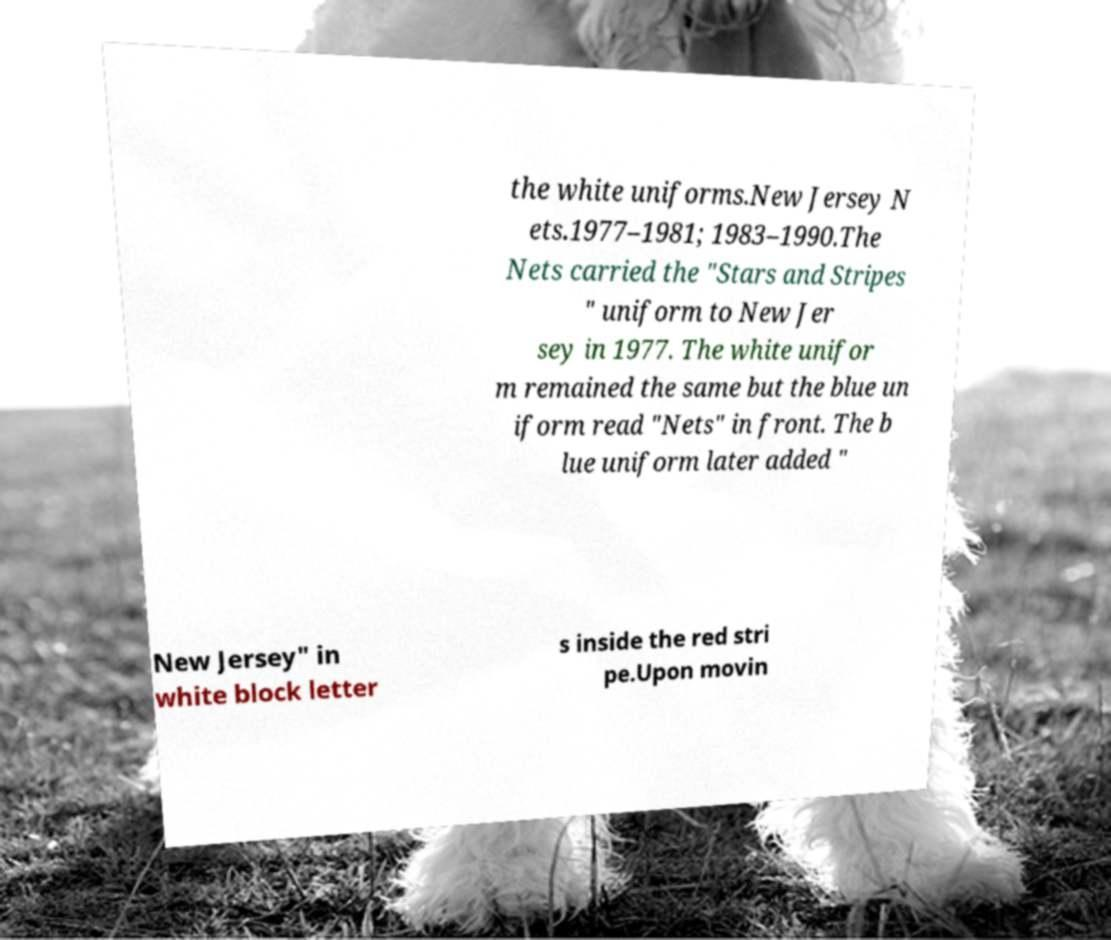I need the written content from this picture converted into text. Can you do that? the white uniforms.New Jersey N ets.1977–1981; 1983–1990.The Nets carried the "Stars and Stripes " uniform to New Jer sey in 1977. The white unifor m remained the same but the blue un iform read "Nets" in front. The b lue uniform later added " New Jersey" in white block letter s inside the red stri pe.Upon movin 